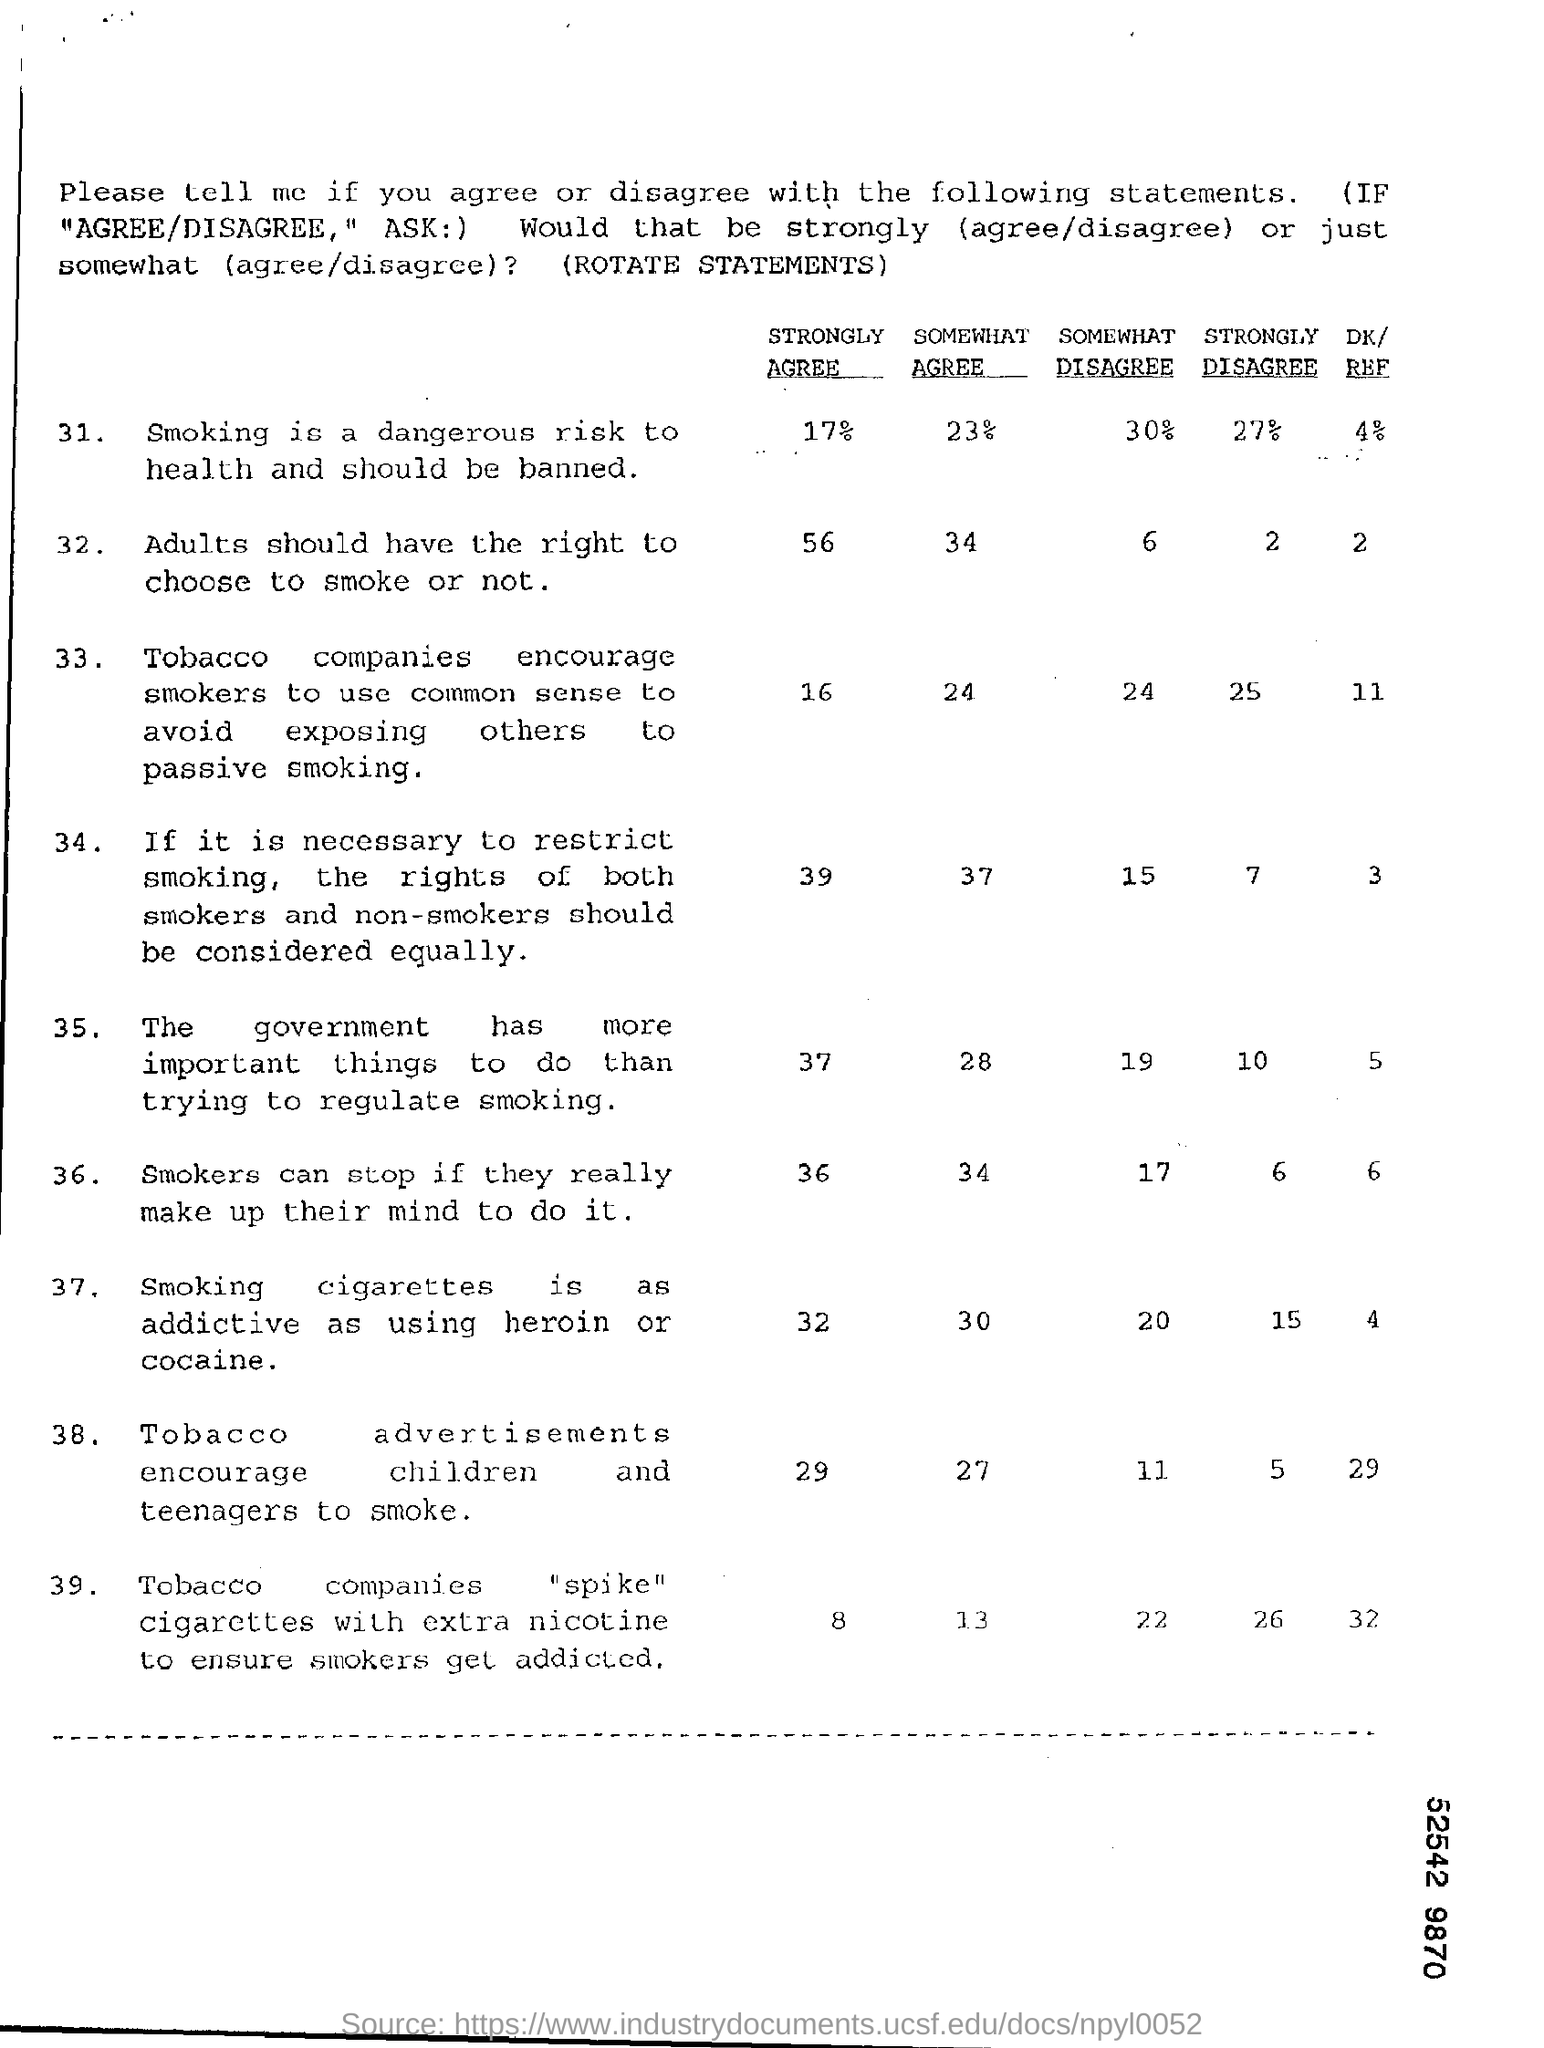Draw attention to some important aspects in this diagram. According to the survey, 27% of people strongly disagree that smoking is a dangerous risk to health and should be banned,"

Note that you can also use "a significant proportion of people" instead of "a large percentage of people" to convey the same meaning. A significant portion of people, approximately 30%, somewhat disagree that smoking is a dangerous risk to health and should be banned. According to the survey, only 4% of people say that smoking is a dangerous risk to health and should be banned. It is estimated that 56% of people strongly agree that adults should have the right to choose to smoke or not. It is estimated that 17% of people strongly agree that smoking is a dangerous risk to health and should be banned. 